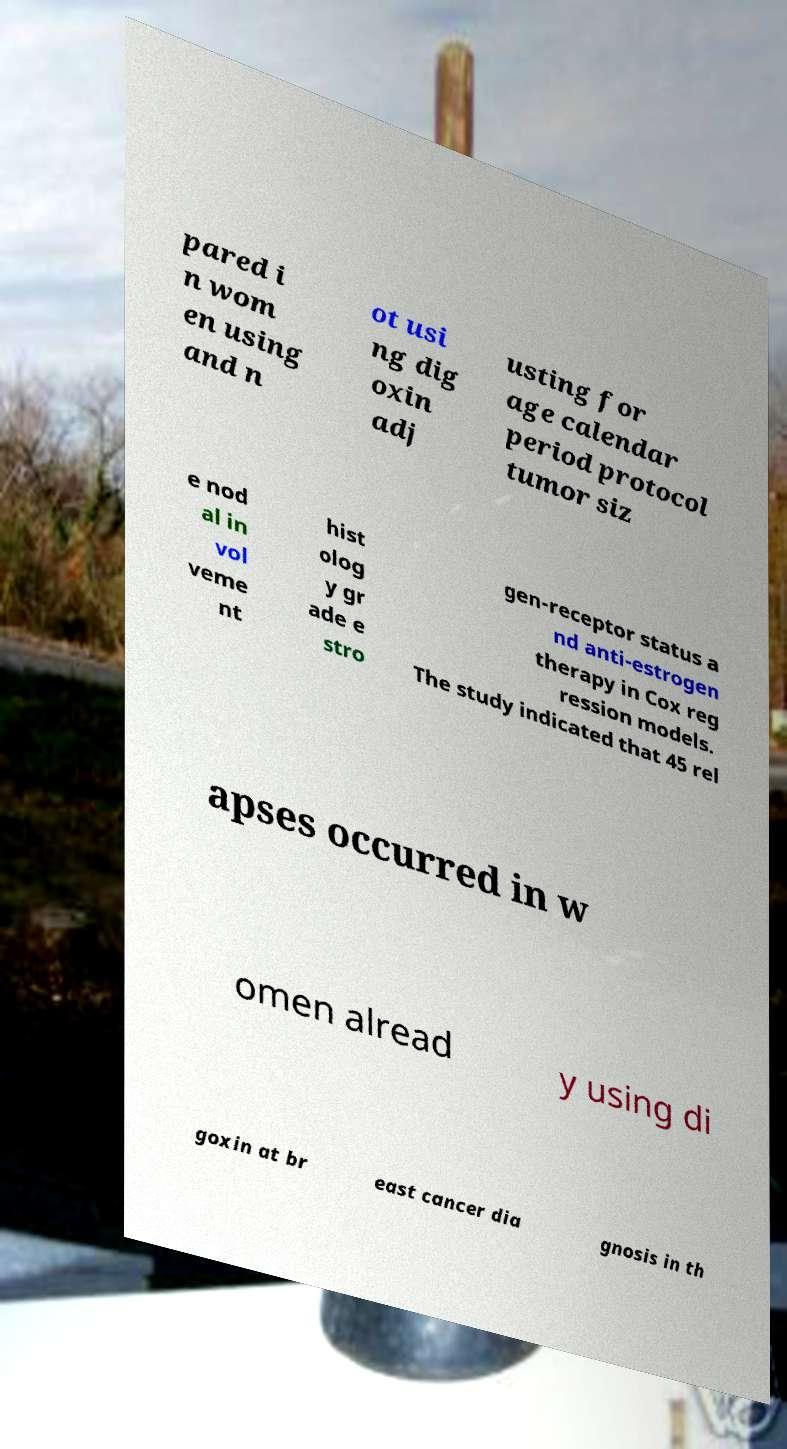Please identify and transcribe the text found in this image. pared i n wom en using and n ot usi ng dig oxin adj usting for age calendar period protocol tumor siz e nod al in vol veme nt hist olog y gr ade e stro gen-receptor status a nd anti-estrogen therapy in Cox reg ression models. The study indicated that 45 rel apses occurred in w omen alread y using di goxin at br east cancer dia gnosis in th 